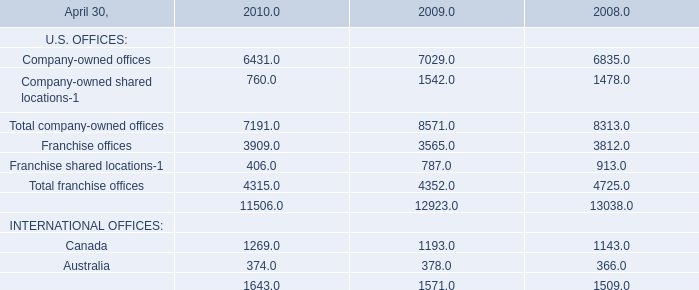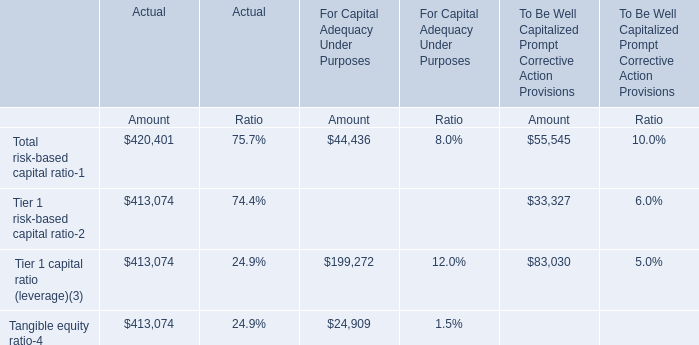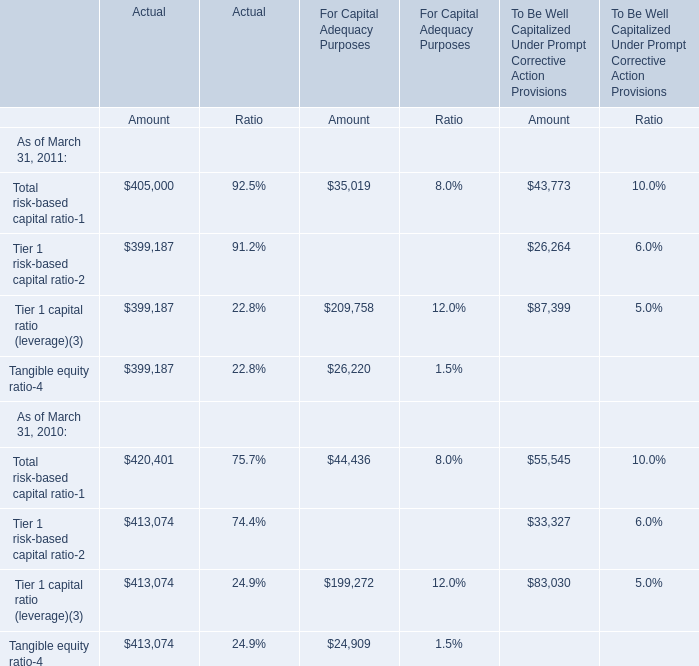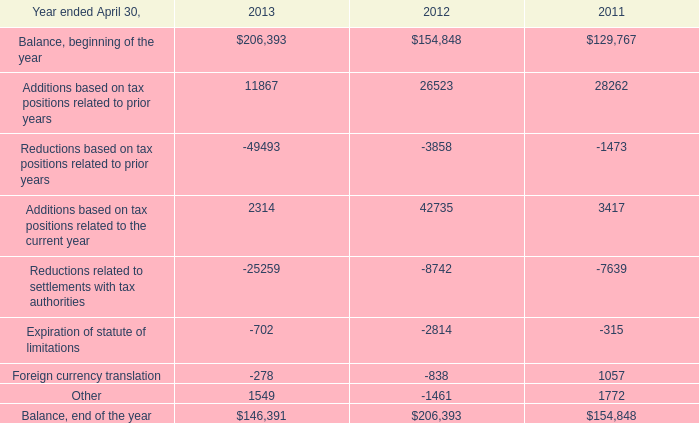How many elements in terms of the Amount for Actual show a value more than 400000 as of March 31, 2011? 
Answer: 1. 